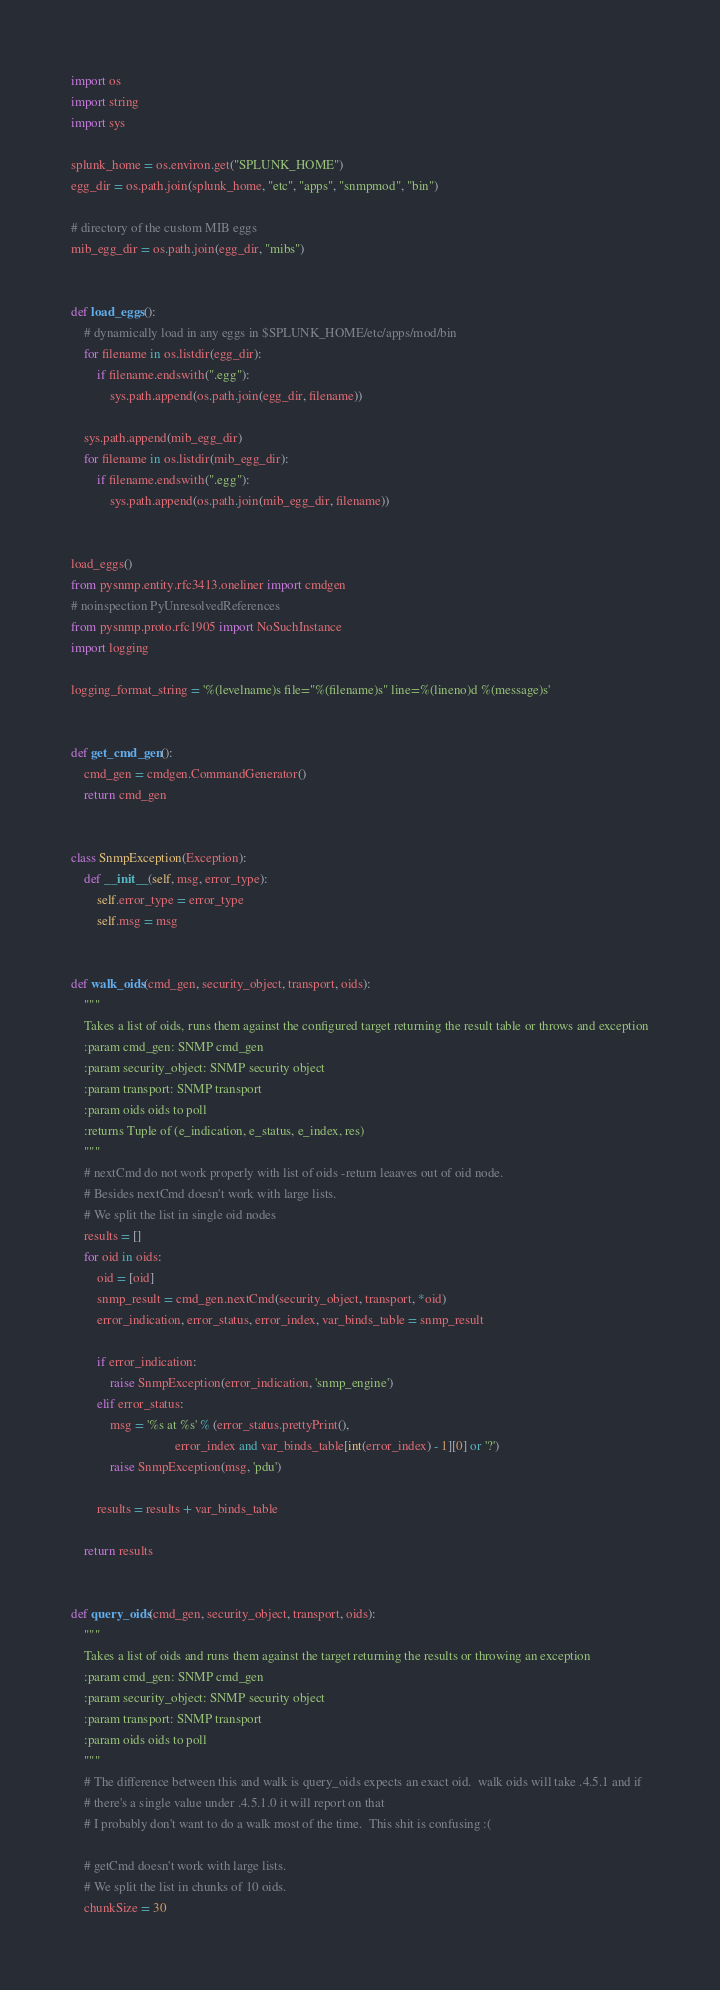Convert code to text. <code><loc_0><loc_0><loc_500><loc_500><_Python_>import os
import string
import sys

splunk_home = os.environ.get("SPLUNK_HOME")
egg_dir = os.path.join(splunk_home, "etc", "apps", "snmpmod", "bin")

# directory of the custom MIB eggs
mib_egg_dir = os.path.join(egg_dir, "mibs")


def load_eggs():
    # dynamically load in any eggs in $SPLUNK_HOME/etc/apps/mod/bin
    for filename in os.listdir(egg_dir):
        if filename.endswith(".egg"):
            sys.path.append(os.path.join(egg_dir, filename))

    sys.path.append(mib_egg_dir)
    for filename in os.listdir(mib_egg_dir):
        if filename.endswith(".egg"):
            sys.path.append(os.path.join(mib_egg_dir, filename))


load_eggs()
from pysnmp.entity.rfc3413.oneliner import cmdgen
# noinspection PyUnresolvedReferences
from pysnmp.proto.rfc1905 import NoSuchInstance
import logging

logging_format_string = '%(levelname)s file="%(filename)s" line=%(lineno)d %(message)s'


def get_cmd_gen():
    cmd_gen = cmdgen.CommandGenerator()
    return cmd_gen


class SnmpException(Exception):
    def __init__(self, msg, error_type):
        self.error_type = error_type
        self.msg = msg


def walk_oids(cmd_gen, security_object, transport, oids):
    """
    Takes a list of oids, runs them against the configured target returning the result table or throws and exception
    :param cmd_gen: SNMP cmd_gen
    :param security_object: SNMP security object
    :param transport: SNMP transport
    :param oids oids to poll
    :returns Tuple of (e_indication, e_status, e_index, res)
    """
    # nextCmd do not work properly with list of oids -return leaaves out of oid node.
    # Besides nextCmd doesn't work with large lists.
    # We split the list in single oid nodes
    results = []
    for oid in oids:
        oid = [oid]
        snmp_result = cmd_gen.nextCmd(security_object, transport, *oid)
        error_indication, error_status, error_index, var_binds_table = snmp_result

        if error_indication:
            raise SnmpException(error_indication, 'snmp_engine')
        elif error_status:
            msg = '%s at %s' % (error_status.prettyPrint(),
                                error_index and var_binds_table[int(error_index) - 1][0] or '?')
            raise SnmpException(msg, 'pdu')

        results = results + var_binds_table

    return results


def query_oids(cmd_gen, security_object, transport, oids):
    """
    Takes a list of oids and runs them against the target returning the results or throwing an exception
    :param cmd_gen: SNMP cmd_gen
    :param security_object: SNMP security object
    :param transport: SNMP transport
    :param oids oids to poll
    """
    # The difference between this and walk is query_oids expects an exact oid.  walk oids will take .4.5.1 and if
    # there's a single value under .4.5.1.0 it will report on that
    # I probably don't want to do a walk most of the time.  This shit is confusing :(

    # getCmd doesn't work with large lists.
    # We split the list in chunks of 10 oids.
    chunkSize = 30</code> 